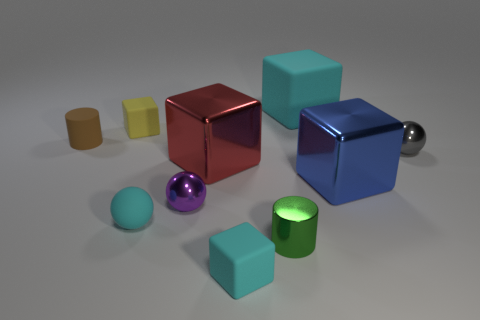How many things are big red cubes or cyan things?
Offer a very short reply. 4. There is a tiny cylinder that is to the right of the sphere in front of the purple object; what is its material?
Your response must be concise. Metal. Is there a matte object that has the same color as the big rubber cube?
Provide a succinct answer. Yes. There is a rubber ball that is the same size as the green object; what is its color?
Your response must be concise. Cyan. The tiny cylinder that is in front of the cylinder that is on the left side of the green object to the right of the tiny purple object is made of what material?
Keep it short and to the point. Metal. There is a large matte object; is its color the same as the tiny cube in front of the green metal object?
Offer a very short reply. Yes. What number of things are either cyan rubber things behind the brown rubber thing or small rubber objects in front of the small rubber cylinder?
Offer a very short reply. 3. What shape is the large object to the left of the small cylinder that is in front of the tiny purple metal sphere?
Give a very brief answer. Cube. Are there any small brown things made of the same material as the cyan sphere?
Make the answer very short. Yes. There is another tiny rubber thing that is the same shape as the tiny purple thing; what color is it?
Ensure brevity in your answer.  Cyan. 